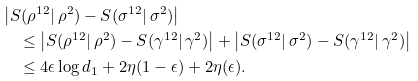<formula> <loc_0><loc_0><loc_500><loc_500>& \left | S ( \rho ^ { 1 2 } | \, \rho ^ { 2 } ) - S ( \sigma ^ { 1 2 } | \, \sigma ^ { 2 } ) \right | \\ & \quad \leq \left | S ( \rho ^ { 1 2 } | \, \rho ^ { 2 } ) - S ( \gamma ^ { 1 2 } | \, \gamma ^ { 2 } ) \right | + \left | S ( \sigma ^ { 1 2 } | \, \sigma ^ { 2 } ) - S ( \gamma ^ { 1 2 } | \, \gamma ^ { 2 } ) \right | \\ & \quad \leq 4 \epsilon \log d _ { 1 } + 2 \eta ( 1 - \epsilon ) + 2 \eta ( \epsilon ) .</formula> 